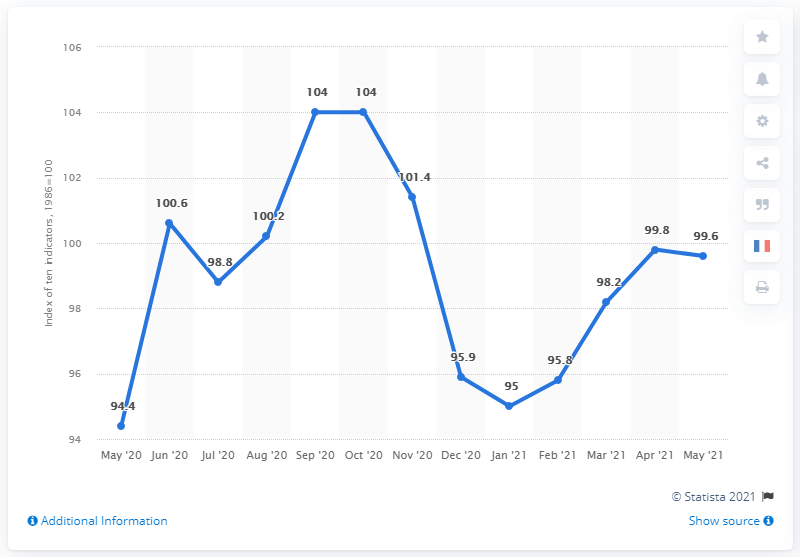Mention a couple of crucial points in this snapshot. The U.S. Small Business Optimism Index value in May 2020 was 94.4. In May 2021, the U.S. Small Business Optimism Index was 99.6, which indicated a high level of confidence and optimism among small businesses in the country. 